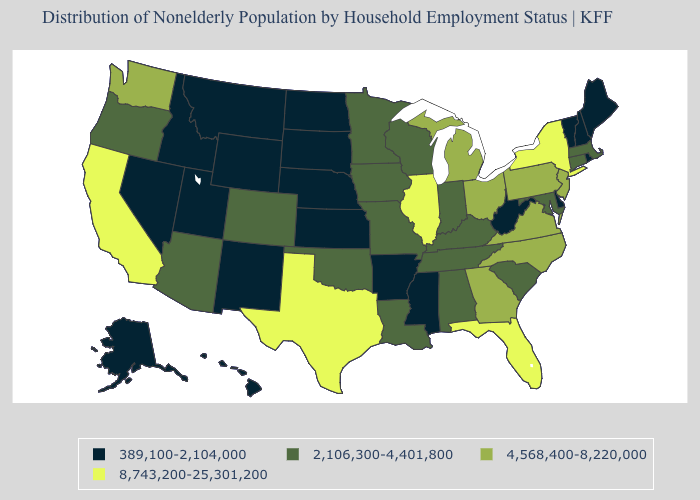Name the states that have a value in the range 4,568,400-8,220,000?
Answer briefly. Georgia, Michigan, New Jersey, North Carolina, Ohio, Pennsylvania, Virginia, Washington. What is the value of Florida?
Short answer required. 8,743,200-25,301,200. What is the value of Missouri?
Answer briefly. 2,106,300-4,401,800. Name the states that have a value in the range 8,743,200-25,301,200?
Answer briefly. California, Florida, Illinois, New York, Texas. What is the highest value in the Northeast ?
Be succinct. 8,743,200-25,301,200. What is the value of Texas?
Give a very brief answer. 8,743,200-25,301,200. Name the states that have a value in the range 8,743,200-25,301,200?
Quick response, please. California, Florida, Illinois, New York, Texas. What is the value of Colorado?
Short answer required. 2,106,300-4,401,800. What is the value of Arkansas?
Answer briefly. 389,100-2,104,000. Does North Dakota have the highest value in the MidWest?
Answer briefly. No. Name the states that have a value in the range 8,743,200-25,301,200?
Quick response, please. California, Florida, Illinois, New York, Texas. Does Louisiana have the same value as Iowa?
Concise answer only. Yes. Name the states that have a value in the range 389,100-2,104,000?
Answer briefly. Alaska, Arkansas, Delaware, Hawaii, Idaho, Kansas, Maine, Mississippi, Montana, Nebraska, Nevada, New Hampshire, New Mexico, North Dakota, Rhode Island, South Dakota, Utah, Vermont, West Virginia, Wyoming. Name the states that have a value in the range 389,100-2,104,000?
Concise answer only. Alaska, Arkansas, Delaware, Hawaii, Idaho, Kansas, Maine, Mississippi, Montana, Nebraska, Nevada, New Hampshire, New Mexico, North Dakota, Rhode Island, South Dakota, Utah, Vermont, West Virginia, Wyoming. What is the lowest value in the USA?
Give a very brief answer. 389,100-2,104,000. 